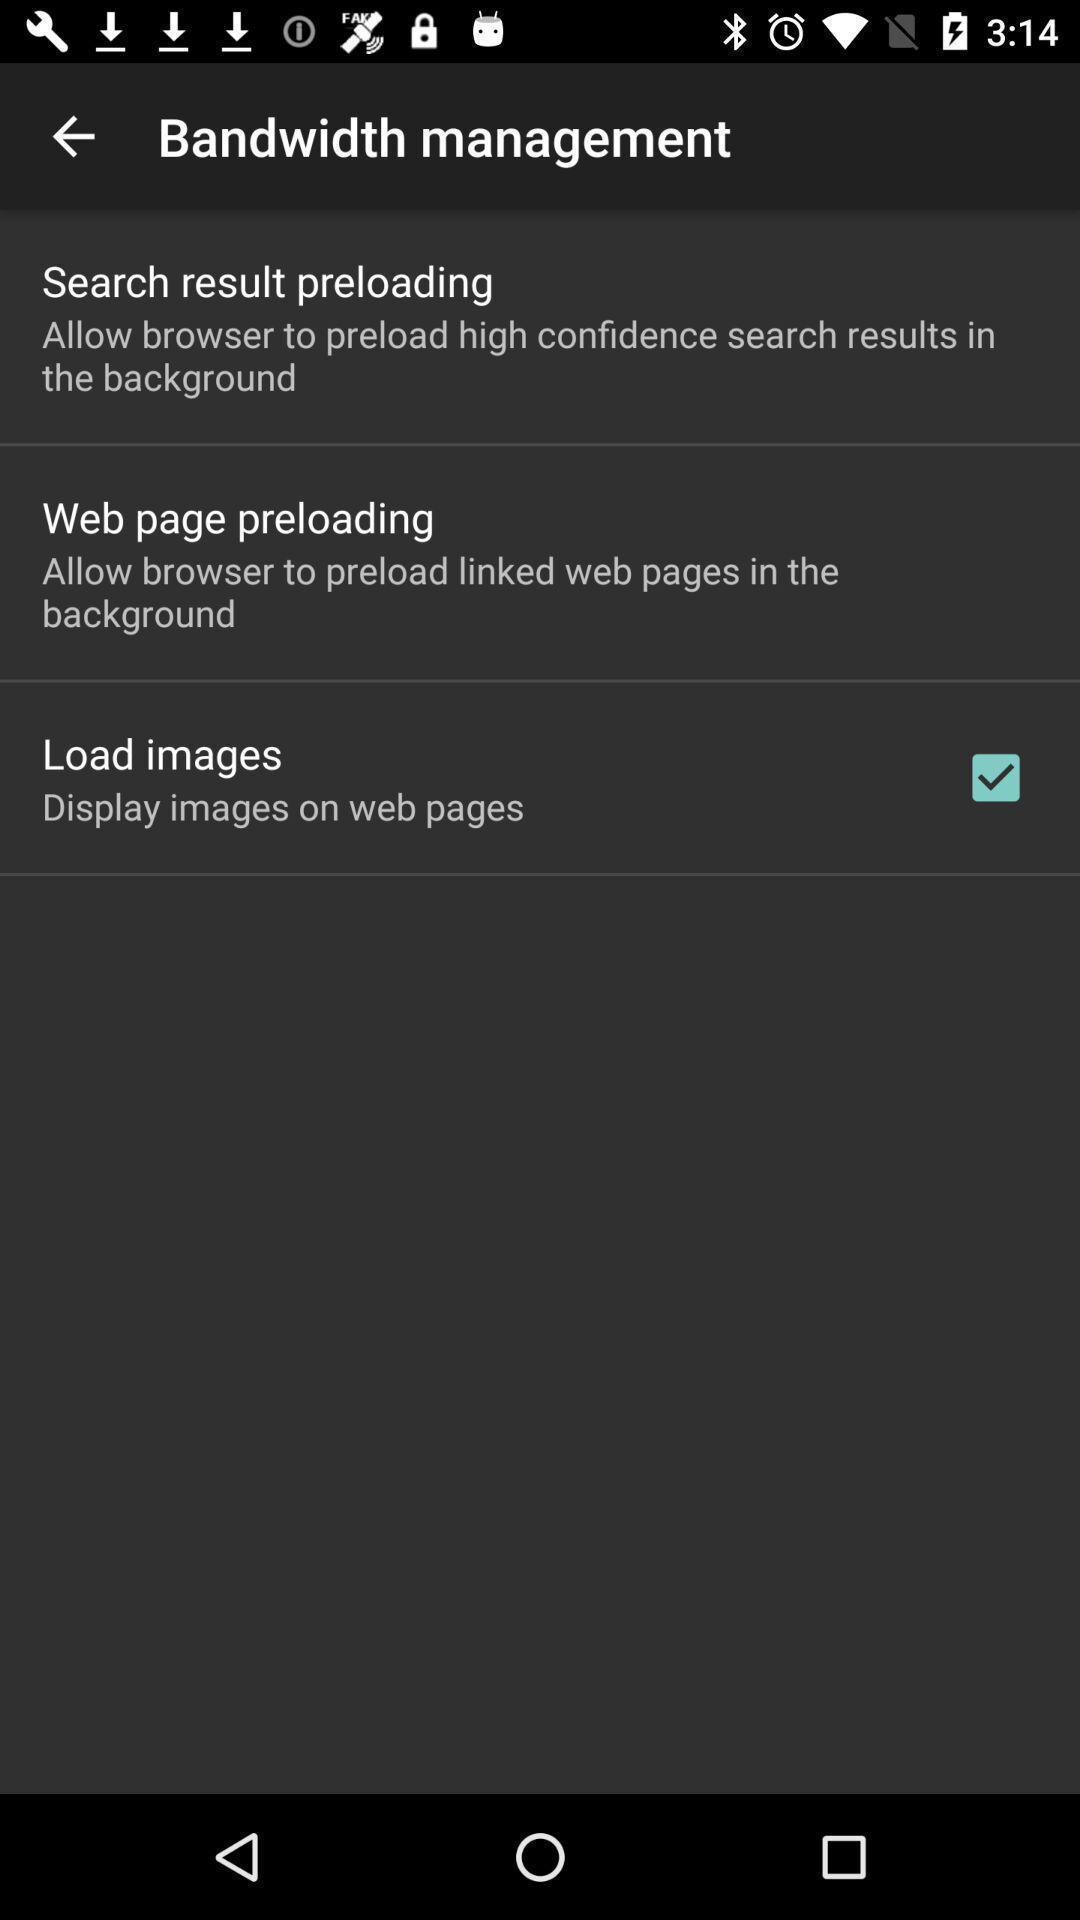Give me a narrative description of this picture. Page displaying the settings. 